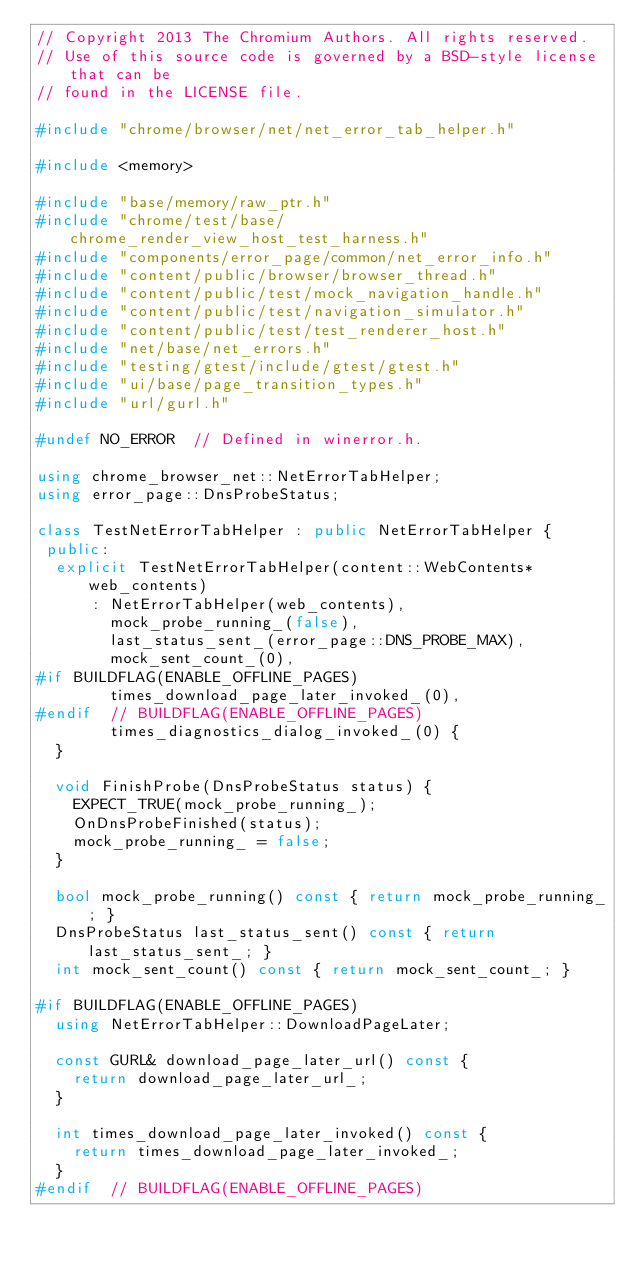<code> <loc_0><loc_0><loc_500><loc_500><_C++_>// Copyright 2013 The Chromium Authors. All rights reserved.
// Use of this source code is governed by a BSD-style license that can be
// found in the LICENSE file.

#include "chrome/browser/net/net_error_tab_helper.h"

#include <memory>

#include "base/memory/raw_ptr.h"
#include "chrome/test/base/chrome_render_view_host_test_harness.h"
#include "components/error_page/common/net_error_info.h"
#include "content/public/browser/browser_thread.h"
#include "content/public/test/mock_navigation_handle.h"
#include "content/public/test/navigation_simulator.h"
#include "content/public/test/test_renderer_host.h"
#include "net/base/net_errors.h"
#include "testing/gtest/include/gtest/gtest.h"
#include "ui/base/page_transition_types.h"
#include "url/gurl.h"

#undef NO_ERROR  // Defined in winerror.h.

using chrome_browser_net::NetErrorTabHelper;
using error_page::DnsProbeStatus;

class TestNetErrorTabHelper : public NetErrorTabHelper {
 public:
  explicit TestNetErrorTabHelper(content::WebContents* web_contents)
      : NetErrorTabHelper(web_contents),
        mock_probe_running_(false),
        last_status_sent_(error_page::DNS_PROBE_MAX),
        mock_sent_count_(0),
#if BUILDFLAG(ENABLE_OFFLINE_PAGES)
        times_download_page_later_invoked_(0),
#endif  // BUILDFLAG(ENABLE_OFFLINE_PAGES)
        times_diagnostics_dialog_invoked_(0) {
  }

  void FinishProbe(DnsProbeStatus status) {
    EXPECT_TRUE(mock_probe_running_);
    OnDnsProbeFinished(status);
    mock_probe_running_ = false;
  }

  bool mock_probe_running() const { return mock_probe_running_; }
  DnsProbeStatus last_status_sent() const { return last_status_sent_; }
  int mock_sent_count() const { return mock_sent_count_; }

#if BUILDFLAG(ENABLE_OFFLINE_PAGES)
  using NetErrorTabHelper::DownloadPageLater;

  const GURL& download_page_later_url() const {
    return download_page_later_url_;
  }

  int times_download_page_later_invoked() const {
    return times_download_page_later_invoked_;
  }
#endif  // BUILDFLAG(ENABLE_OFFLINE_PAGES)
</code> 